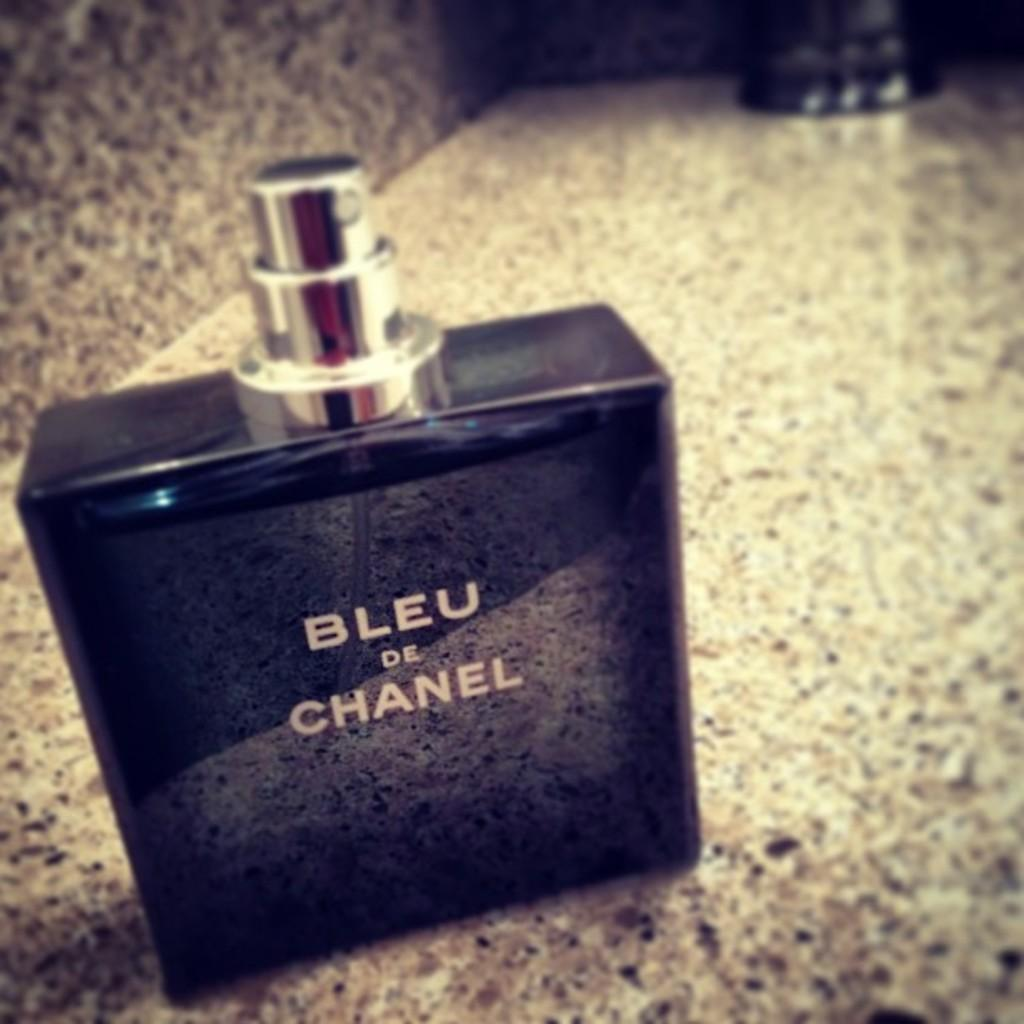<image>
Relay a brief, clear account of the picture shown. A small bottle of Bleu de Chanel on top of a granite counter 